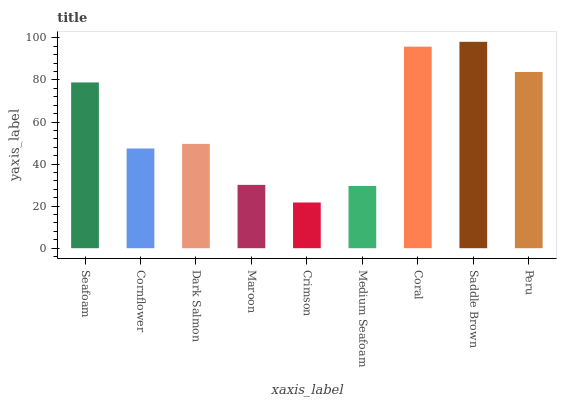Is Cornflower the minimum?
Answer yes or no. No. Is Cornflower the maximum?
Answer yes or no. No. Is Seafoam greater than Cornflower?
Answer yes or no. Yes. Is Cornflower less than Seafoam?
Answer yes or no. Yes. Is Cornflower greater than Seafoam?
Answer yes or no. No. Is Seafoam less than Cornflower?
Answer yes or no. No. Is Dark Salmon the high median?
Answer yes or no. Yes. Is Dark Salmon the low median?
Answer yes or no. Yes. Is Medium Seafoam the high median?
Answer yes or no. No. Is Coral the low median?
Answer yes or no. No. 